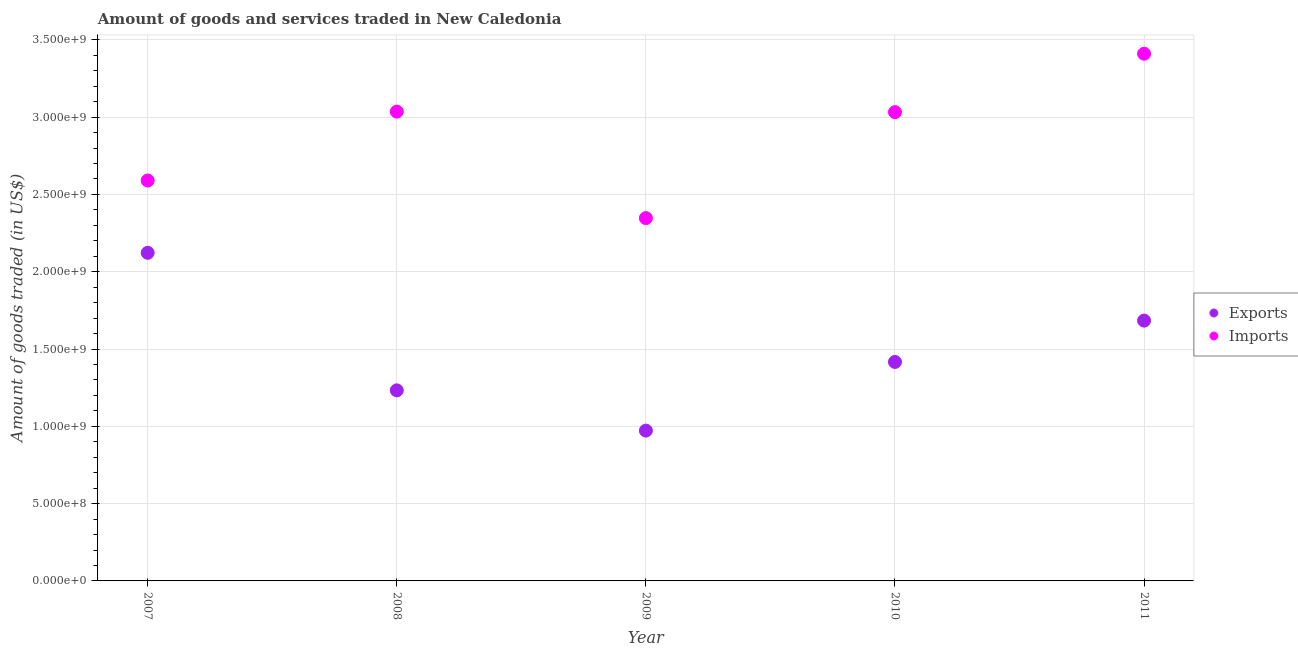What is the amount of goods exported in 2008?
Offer a very short reply. 1.23e+09. Across all years, what is the maximum amount of goods exported?
Offer a very short reply. 2.12e+09. Across all years, what is the minimum amount of goods imported?
Offer a very short reply. 2.35e+09. What is the total amount of goods imported in the graph?
Ensure brevity in your answer.  1.44e+1. What is the difference between the amount of goods exported in 2009 and that in 2010?
Offer a very short reply. -4.44e+08. What is the difference between the amount of goods imported in 2010 and the amount of goods exported in 2008?
Your response must be concise. 1.80e+09. What is the average amount of goods imported per year?
Give a very brief answer. 2.88e+09. In the year 2010, what is the difference between the amount of goods exported and amount of goods imported?
Provide a short and direct response. -1.62e+09. In how many years, is the amount of goods imported greater than 1600000000 US$?
Make the answer very short. 5. What is the ratio of the amount of goods exported in 2010 to that in 2011?
Provide a short and direct response. 0.84. Is the amount of goods imported in 2007 less than that in 2009?
Ensure brevity in your answer.  No. What is the difference between the highest and the second highest amount of goods imported?
Your answer should be compact. 3.74e+08. What is the difference between the highest and the lowest amount of goods imported?
Keep it short and to the point. 1.06e+09. Is the sum of the amount of goods exported in 2007 and 2011 greater than the maximum amount of goods imported across all years?
Ensure brevity in your answer.  Yes. Does the amount of goods imported monotonically increase over the years?
Offer a terse response. No. Is the amount of goods imported strictly less than the amount of goods exported over the years?
Give a very brief answer. No. How many dotlines are there?
Keep it short and to the point. 2. Does the graph contain any zero values?
Make the answer very short. No. Where does the legend appear in the graph?
Ensure brevity in your answer.  Center right. How many legend labels are there?
Offer a terse response. 2. How are the legend labels stacked?
Make the answer very short. Vertical. What is the title of the graph?
Give a very brief answer. Amount of goods and services traded in New Caledonia. Does "Non-solid fuel" appear as one of the legend labels in the graph?
Provide a succinct answer. No. What is the label or title of the X-axis?
Your answer should be compact. Year. What is the label or title of the Y-axis?
Provide a succinct answer. Amount of goods traded (in US$). What is the Amount of goods traded (in US$) in Exports in 2007?
Offer a terse response. 2.12e+09. What is the Amount of goods traded (in US$) in Imports in 2007?
Your answer should be compact. 2.59e+09. What is the Amount of goods traded (in US$) in Exports in 2008?
Provide a succinct answer. 1.23e+09. What is the Amount of goods traded (in US$) of Imports in 2008?
Make the answer very short. 3.04e+09. What is the Amount of goods traded (in US$) in Exports in 2009?
Your response must be concise. 9.72e+08. What is the Amount of goods traded (in US$) in Imports in 2009?
Make the answer very short. 2.35e+09. What is the Amount of goods traded (in US$) in Exports in 2010?
Give a very brief answer. 1.42e+09. What is the Amount of goods traded (in US$) in Imports in 2010?
Keep it short and to the point. 3.03e+09. What is the Amount of goods traded (in US$) in Exports in 2011?
Offer a terse response. 1.68e+09. What is the Amount of goods traded (in US$) in Imports in 2011?
Your response must be concise. 3.41e+09. Across all years, what is the maximum Amount of goods traded (in US$) of Exports?
Offer a very short reply. 2.12e+09. Across all years, what is the maximum Amount of goods traded (in US$) of Imports?
Offer a very short reply. 3.41e+09. Across all years, what is the minimum Amount of goods traded (in US$) of Exports?
Provide a short and direct response. 9.72e+08. Across all years, what is the minimum Amount of goods traded (in US$) of Imports?
Your response must be concise. 2.35e+09. What is the total Amount of goods traded (in US$) of Exports in the graph?
Ensure brevity in your answer.  7.43e+09. What is the total Amount of goods traded (in US$) in Imports in the graph?
Provide a succinct answer. 1.44e+1. What is the difference between the Amount of goods traded (in US$) in Exports in 2007 and that in 2008?
Your answer should be compact. 8.90e+08. What is the difference between the Amount of goods traded (in US$) in Imports in 2007 and that in 2008?
Your response must be concise. -4.46e+08. What is the difference between the Amount of goods traded (in US$) of Exports in 2007 and that in 2009?
Make the answer very short. 1.15e+09. What is the difference between the Amount of goods traded (in US$) in Imports in 2007 and that in 2009?
Your answer should be very brief. 2.43e+08. What is the difference between the Amount of goods traded (in US$) of Exports in 2007 and that in 2010?
Provide a succinct answer. 7.06e+08. What is the difference between the Amount of goods traded (in US$) of Imports in 2007 and that in 2010?
Offer a very short reply. -4.42e+08. What is the difference between the Amount of goods traded (in US$) of Exports in 2007 and that in 2011?
Give a very brief answer. 4.38e+08. What is the difference between the Amount of goods traded (in US$) in Imports in 2007 and that in 2011?
Provide a short and direct response. -8.20e+08. What is the difference between the Amount of goods traded (in US$) in Exports in 2008 and that in 2009?
Keep it short and to the point. 2.60e+08. What is the difference between the Amount of goods traded (in US$) in Imports in 2008 and that in 2009?
Your response must be concise. 6.89e+08. What is the difference between the Amount of goods traded (in US$) in Exports in 2008 and that in 2010?
Offer a very short reply. -1.84e+08. What is the difference between the Amount of goods traded (in US$) in Imports in 2008 and that in 2010?
Make the answer very short. 3.46e+06. What is the difference between the Amount of goods traded (in US$) of Exports in 2008 and that in 2011?
Provide a short and direct response. -4.51e+08. What is the difference between the Amount of goods traded (in US$) of Imports in 2008 and that in 2011?
Offer a very short reply. -3.74e+08. What is the difference between the Amount of goods traded (in US$) of Exports in 2009 and that in 2010?
Offer a terse response. -4.44e+08. What is the difference between the Amount of goods traded (in US$) of Imports in 2009 and that in 2010?
Provide a succinct answer. -6.85e+08. What is the difference between the Amount of goods traded (in US$) of Exports in 2009 and that in 2011?
Offer a terse response. -7.12e+08. What is the difference between the Amount of goods traded (in US$) in Imports in 2009 and that in 2011?
Your response must be concise. -1.06e+09. What is the difference between the Amount of goods traded (in US$) in Exports in 2010 and that in 2011?
Ensure brevity in your answer.  -2.67e+08. What is the difference between the Amount of goods traded (in US$) of Imports in 2010 and that in 2011?
Your answer should be very brief. -3.78e+08. What is the difference between the Amount of goods traded (in US$) of Exports in 2007 and the Amount of goods traded (in US$) of Imports in 2008?
Give a very brief answer. -9.13e+08. What is the difference between the Amount of goods traded (in US$) in Exports in 2007 and the Amount of goods traded (in US$) in Imports in 2009?
Provide a short and direct response. -2.25e+08. What is the difference between the Amount of goods traded (in US$) of Exports in 2007 and the Amount of goods traded (in US$) of Imports in 2010?
Give a very brief answer. -9.10e+08. What is the difference between the Amount of goods traded (in US$) of Exports in 2007 and the Amount of goods traded (in US$) of Imports in 2011?
Offer a terse response. -1.29e+09. What is the difference between the Amount of goods traded (in US$) of Exports in 2008 and the Amount of goods traded (in US$) of Imports in 2009?
Your response must be concise. -1.11e+09. What is the difference between the Amount of goods traded (in US$) of Exports in 2008 and the Amount of goods traded (in US$) of Imports in 2010?
Your response must be concise. -1.80e+09. What is the difference between the Amount of goods traded (in US$) of Exports in 2008 and the Amount of goods traded (in US$) of Imports in 2011?
Ensure brevity in your answer.  -2.18e+09. What is the difference between the Amount of goods traded (in US$) of Exports in 2009 and the Amount of goods traded (in US$) of Imports in 2010?
Offer a terse response. -2.06e+09. What is the difference between the Amount of goods traded (in US$) of Exports in 2009 and the Amount of goods traded (in US$) of Imports in 2011?
Offer a very short reply. -2.44e+09. What is the difference between the Amount of goods traded (in US$) in Exports in 2010 and the Amount of goods traded (in US$) in Imports in 2011?
Ensure brevity in your answer.  -1.99e+09. What is the average Amount of goods traded (in US$) of Exports per year?
Make the answer very short. 1.49e+09. What is the average Amount of goods traded (in US$) in Imports per year?
Ensure brevity in your answer.  2.88e+09. In the year 2007, what is the difference between the Amount of goods traded (in US$) in Exports and Amount of goods traded (in US$) in Imports?
Provide a succinct answer. -4.68e+08. In the year 2008, what is the difference between the Amount of goods traded (in US$) in Exports and Amount of goods traded (in US$) in Imports?
Your response must be concise. -1.80e+09. In the year 2009, what is the difference between the Amount of goods traded (in US$) of Exports and Amount of goods traded (in US$) of Imports?
Provide a succinct answer. -1.37e+09. In the year 2010, what is the difference between the Amount of goods traded (in US$) in Exports and Amount of goods traded (in US$) in Imports?
Your answer should be very brief. -1.62e+09. In the year 2011, what is the difference between the Amount of goods traded (in US$) of Exports and Amount of goods traded (in US$) of Imports?
Provide a succinct answer. -1.73e+09. What is the ratio of the Amount of goods traded (in US$) of Exports in 2007 to that in 2008?
Offer a very short reply. 1.72. What is the ratio of the Amount of goods traded (in US$) of Imports in 2007 to that in 2008?
Ensure brevity in your answer.  0.85. What is the ratio of the Amount of goods traded (in US$) in Exports in 2007 to that in 2009?
Offer a terse response. 2.18. What is the ratio of the Amount of goods traded (in US$) in Imports in 2007 to that in 2009?
Provide a succinct answer. 1.1. What is the ratio of the Amount of goods traded (in US$) of Exports in 2007 to that in 2010?
Ensure brevity in your answer.  1.5. What is the ratio of the Amount of goods traded (in US$) in Imports in 2007 to that in 2010?
Offer a terse response. 0.85. What is the ratio of the Amount of goods traded (in US$) of Exports in 2007 to that in 2011?
Provide a short and direct response. 1.26. What is the ratio of the Amount of goods traded (in US$) of Imports in 2007 to that in 2011?
Your response must be concise. 0.76. What is the ratio of the Amount of goods traded (in US$) in Exports in 2008 to that in 2009?
Your answer should be very brief. 1.27. What is the ratio of the Amount of goods traded (in US$) of Imports in 2008 to that in 2009?
Your answer should be compact. 1.29. What is the ratio of the Amount of goods traded (in US$) of Exports in 2008 to that in 2010?
Make the answer very short. 0.87. What is the ratio of the Amount of goods traded (in US$) of Imports in 2008 to that in 2010?
Your answer should be very brief. 1. What is the ratio of the Amount of goods traded (in US$) in Exports in 2008 to that in 2011?
Offer a very short reply. 0.73. What is the ratio of the Amount of goods traded (in US$) of Imports in 2008 to that in 2011?
Provide a short and direct response. 0.89. What is the ratio of the Amount of goods traded (in US$) of Exports in 2009 to that in 2010?
Your response must be concise. 0.69. What is the ratio of the Amount of goods traded (in US$) of Imports in 2009 to that in 2010?
Give a very brief answer. 0.77. What is the ratio of the Amount of goods traded (in US$) in Exports in 2009 to that in 2011?
Ensure brevity in your answer.  0.58. What is the ratio of the Amount of goods traded (in US$) in Imports in 2009 to that in 2011?
Offer a very short reply. 0.69. What is the ratio of the Amount of goods traded (in US$) in Exports in 2010 to that in 2011?
Your answer should be compact. 0.84. What is the ratio of the Amount of goods traded (in US$) in Imports in 2010 to that in 2011?
Your response must be concise. 0.89. What is the difference between the highest and the second highest Amount of goods traded (in US$) in Exports?
Keep it short and to the point. 4.38e+08. What is the difference between the highest and the second highest Amount of goods traded (in US$) of Imports?
Your answer should be very brief. 3.74e+08. What is the difference between the highest and the lowest Amount of goods traded (in US$) of Exports?
Your answer should be very brief. 1.15e+09. What is the difference between the highest and the lowest Amount of goods traded (in US$) in Imports?
Give a very brief answer. 1.06e+09. 